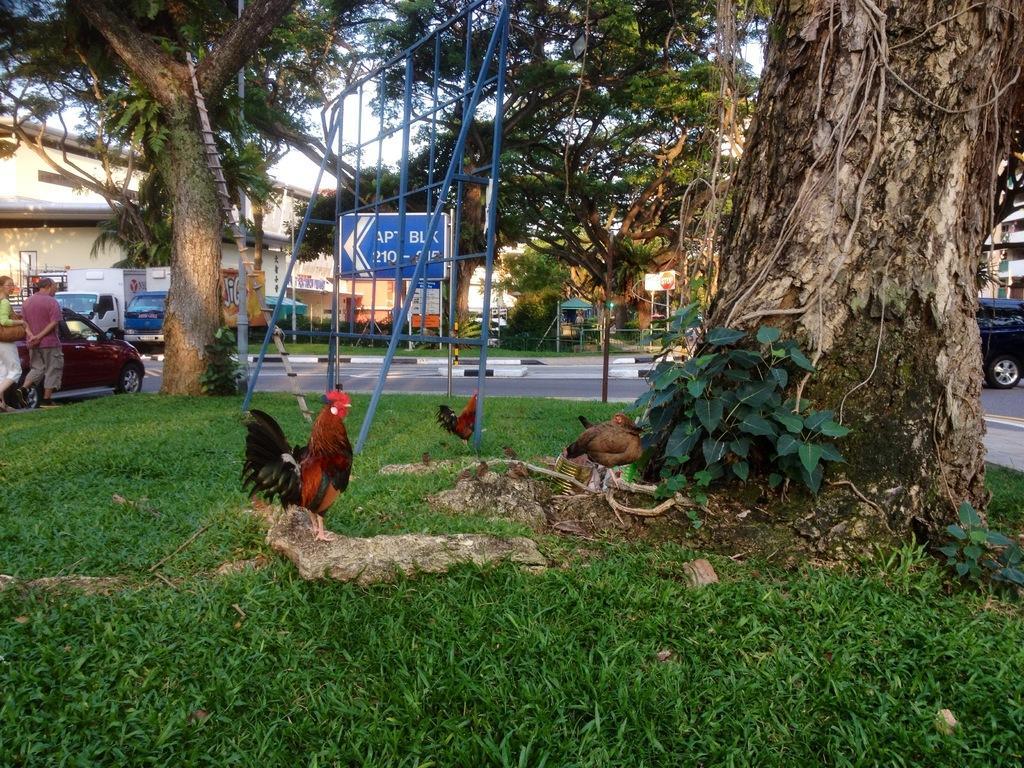Please provide a concise description of this image. In this image we can see hens, trees, iron objects and other objects. In the background of the image there are buildings, name boards, vehicles, road, people, trees and other objects. At the bottom of the image there is the grass. 